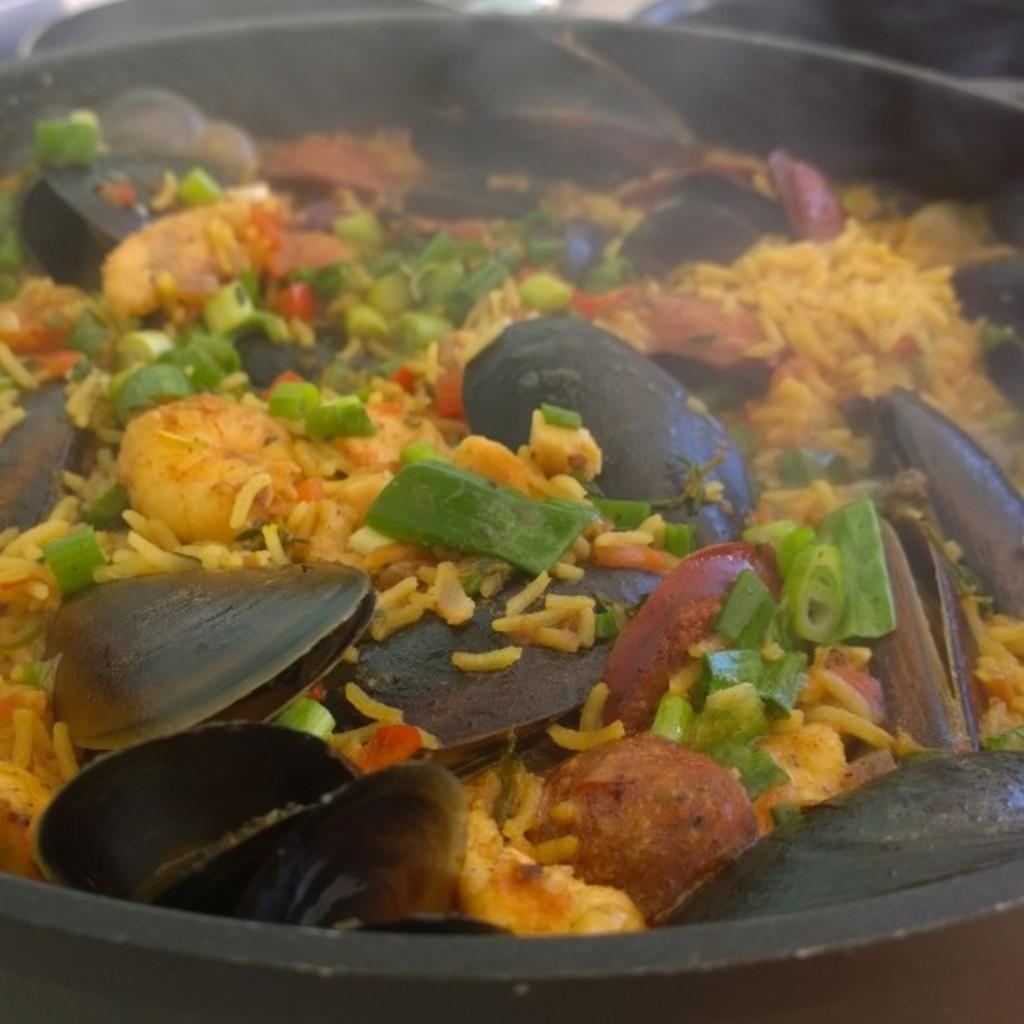What color is the bowl in the image? The bowl in the image is black colored. What is inside the bowl? The bowl contains a food item. Can you describe the food item in the bowl? The food item has yellow, green, black, red, and orange colors. What other objects are present in the bowl? There are seashells in the bowl. How many eggs are visible in the image? There are no eggs visible in the image. What type of rings can be seen on the food item in the image? There are no rings present on the food item in the image. 